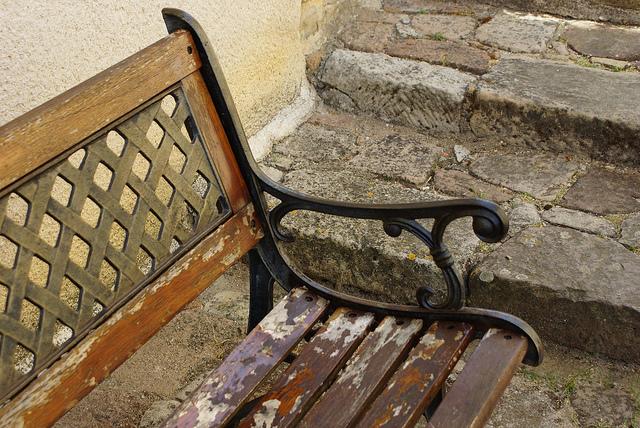Besides wood, what is the bench made of?
Concise answer only. Metal. Is the wood wearing off on this bench?
Quick response, please. Yes. How many steps are visible?
Concise answer only. 2. 